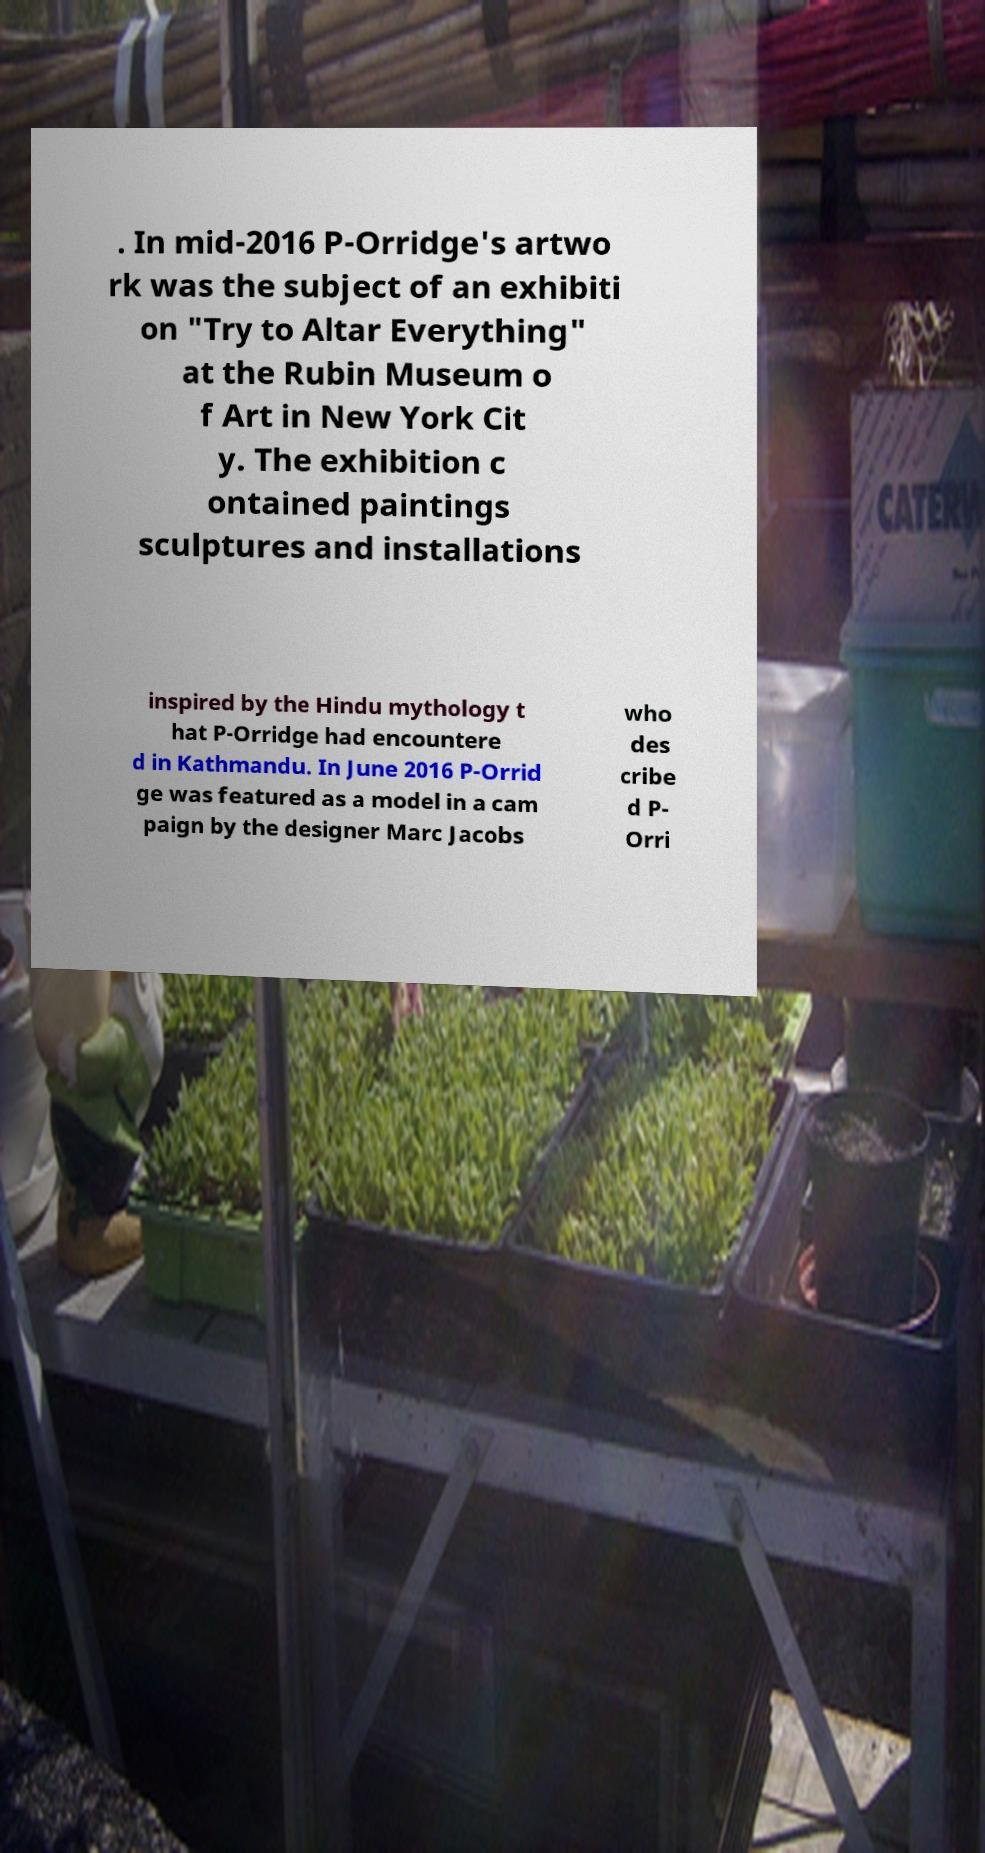I need the written content from this picture converted into text. Can you do that? . In mid-2016 P-Orridge's artwo rk was the subject of an exhibiti on "Try to Altar Everything" at the Rubin Museum o f Art in New York Cit y. The exhibition c ontained paintings sculptures and installations inspired by the Hindu mythology t hat P-Orridge had encountere d in Kathmandu. In June 2016 P-Orrid ge was featured as a model in a cam paign by the designer Marc Jacobs who des cribe d P- Orri 